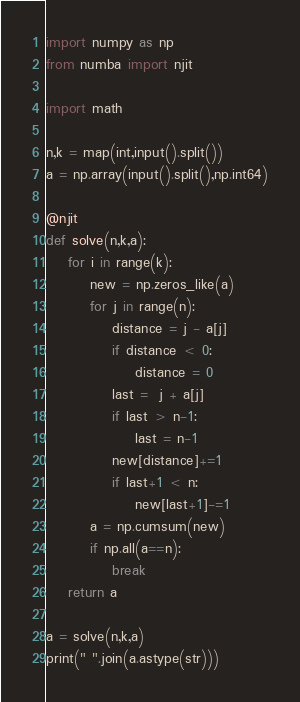<code> <loc_0><loc_0><loc_500><loc_500><_Python_>
import numpy as np
from numba import njit

import math

n,k = map(int,input().split())
a = np.array(input().split(),np.int64)

@njit
def solve(n,k,a):
    for i in range(k):
        new = np.zeros_like(a)
        for j in range(n):
            distance = j - a[j]
            if distance < 0:
                distance = 0
            last =  j + a[j]
            if last > n-1:
                last = n-1
            new[distance]+=1
            if last+1 < n:
                new[last+1]-=1
        a = np.cumsum(new)
        if np.all(a==n):
            break
    return a

a = solve(n,k,a)
print(" ".join(a.astype(str)))</code> 